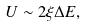<formula> <loc_0><loc_0><loc_500><loc_500>U \sim 2 \xi \Delta E ,</formula> 